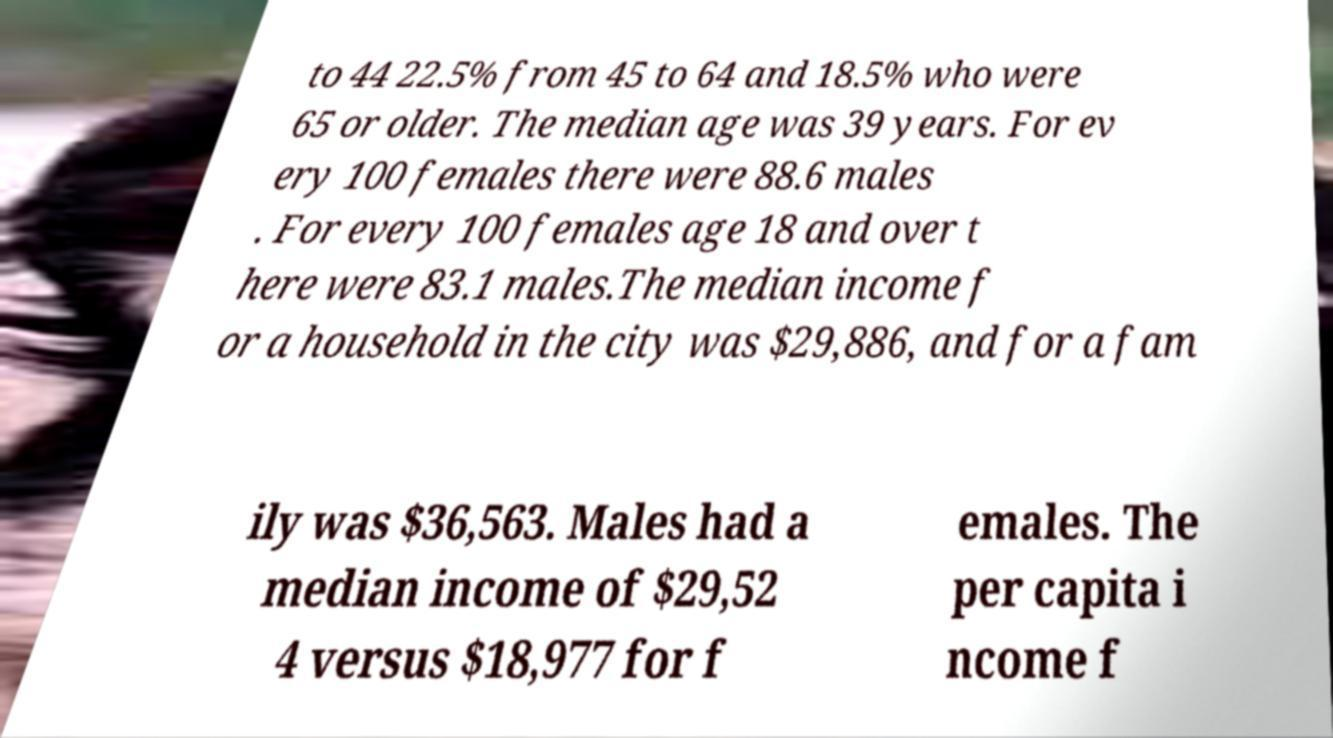Can you read and provide the text displayed in the image?This photo seems to have some interesting text. Can you extract and type it out for me? to 44 22.5% from 45 to 64 and 18.5% who were 65 or older. The median age was 39 years. For ev ery 100 females there were 88.6 males . For every 100 females age 18 and over t here were 83.1 males.The median income f or a household in the city was $29,886, and for a fam ily was $36,563. Males had a median income of $29,52 4 versus $18,977 for f emales. The per capita i ncome f 